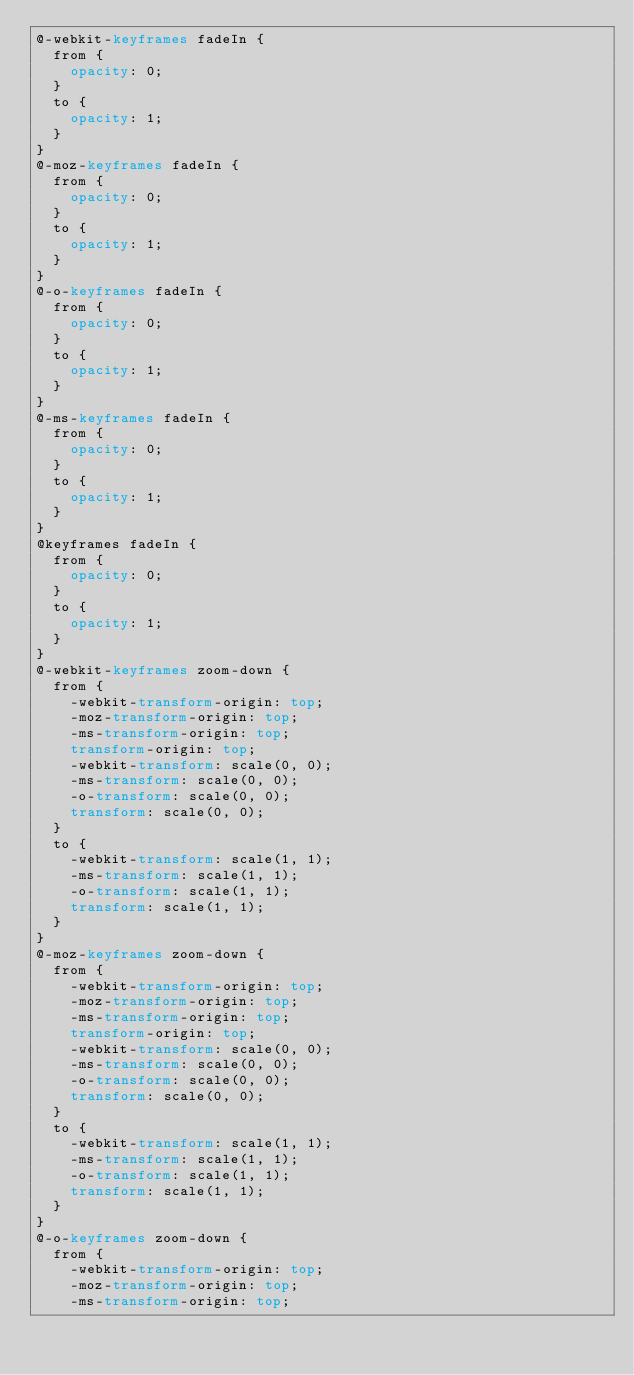<code> <loc_0><loc_0><loc_500><loc_500><_CSS_>@-webkit-keyframes fadeIn {
  from {
    opacity: 0;
  }
  to {
    opacity: 1;
  }
}
@-moz-keyframes fadeIn {
  from {
    opacity: 0;
  }
  to {
    opacity: 1;
  }
}
@-o-keyframes fadeIn {
  from {
    opacity: 0;
  }
  to {
    opacity: 1;
  }
}
@-ms-keyframes fadeIn {
  from {
    opacity: 0;
  }
  to {
    opacity: 1;
  }
}
@keyframes fadeIn {
  from {
    opacity: 0;
  }
  to {
    opacity: 1;
  }
}
@-webkit-keyframes zoom-down {
  from {
    -webkit-transform-origin: top;
    -moz-transform-origin: top;
    -ms-transform-origin: top;
    transform-origin: top;
    -webkit-transform: scale(0, 0);
    -ms-transform: scale(0, 0);
    -o-transform: scale(0, 0);
    transform: scale(0, 0);
  }
  to {
    -webkit-transform: scale(1, 1);
    -ms-transform: scale(1, 1);
    -o-transform: scale(1, 1);
    transform: scale(1, 1);
  }
}
@-moz-keyframes zoom-down {
  from {
    -webkit-transform-origin: top;
    -moz-transform-origin: top;
    -ms-transform-origin: top;
    transform-origin: top;
    -webkit-transform: scale(0, 0);
    -ms-transform: scale(0, 0);
    -o-transform: scale(0, 0);
    transform: scale(0, 0);
  }
  to {
    -webkit-transform: scale(1, 1);
    -ms-transform: scale(1, 1);
    -o-transform: scale(1, 1);
    transform: scale(1, 1);
  }
}
@-o-keyframes zoom-down {
  from {
    -webkit-transform-origin: top;
    -moz-transform-origin: top;
    -ms-transform-origin: top;</code> 